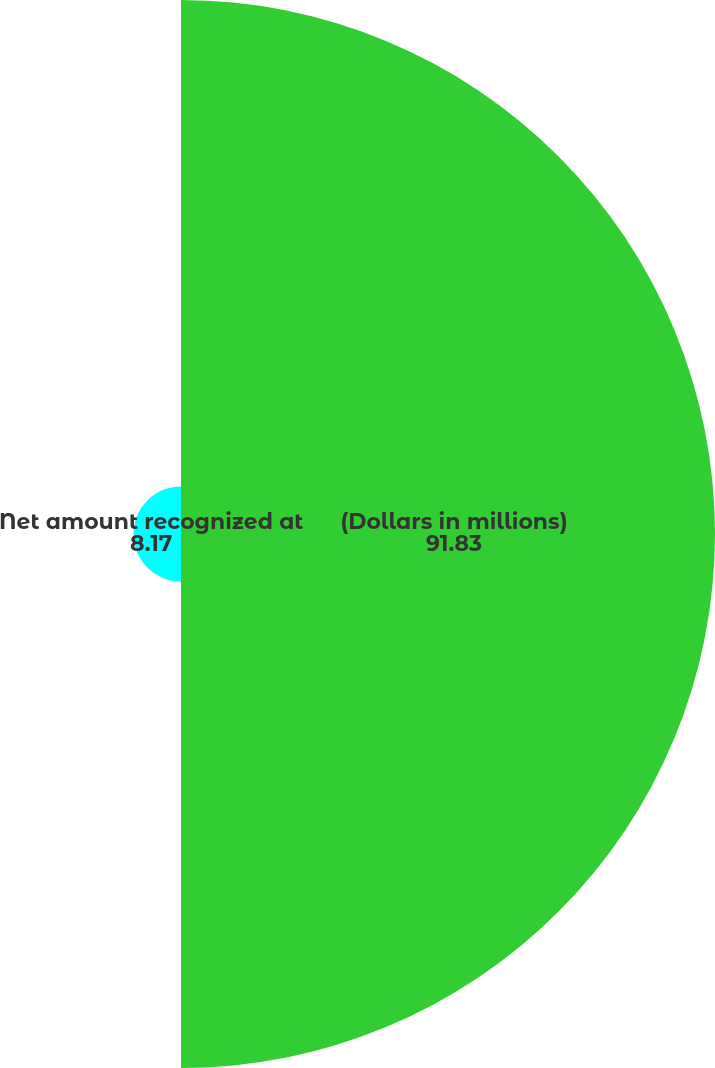<chart> <loc_0><loc_0><loc_500><loc_500><pie_chart><fcel>(Dollars in millions)<fcel>Net amount recognized at<nl><fcel>91.83%<fcel>8.17%<nl></chart> 